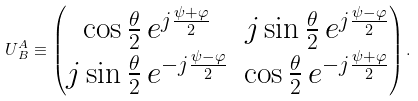Convert formula to latex. <formula><loc_0><loc_0><loc_500><loc_500>U ^ { A } _ { \, B } \equiv \begin{pmatrix} \cos \frac { \theta } { 2 } \, e ^ { j \frac { \psi + \varphi } { 2 } } & j \sin \frac { \theta } { 2 } \, e ^ { j \frac { \psi - \varphi } { 2 } } \\ j \sin \frac { \theta } { 2 } \, e ^ { - j \frac { \psi - \varphi } { 2 } } & \cos \frac { \theta } { 2 } \, e ^ { - j \frac { \psi + \varphi } { 2 } } \\ \end{pmatrix} .</formula> 